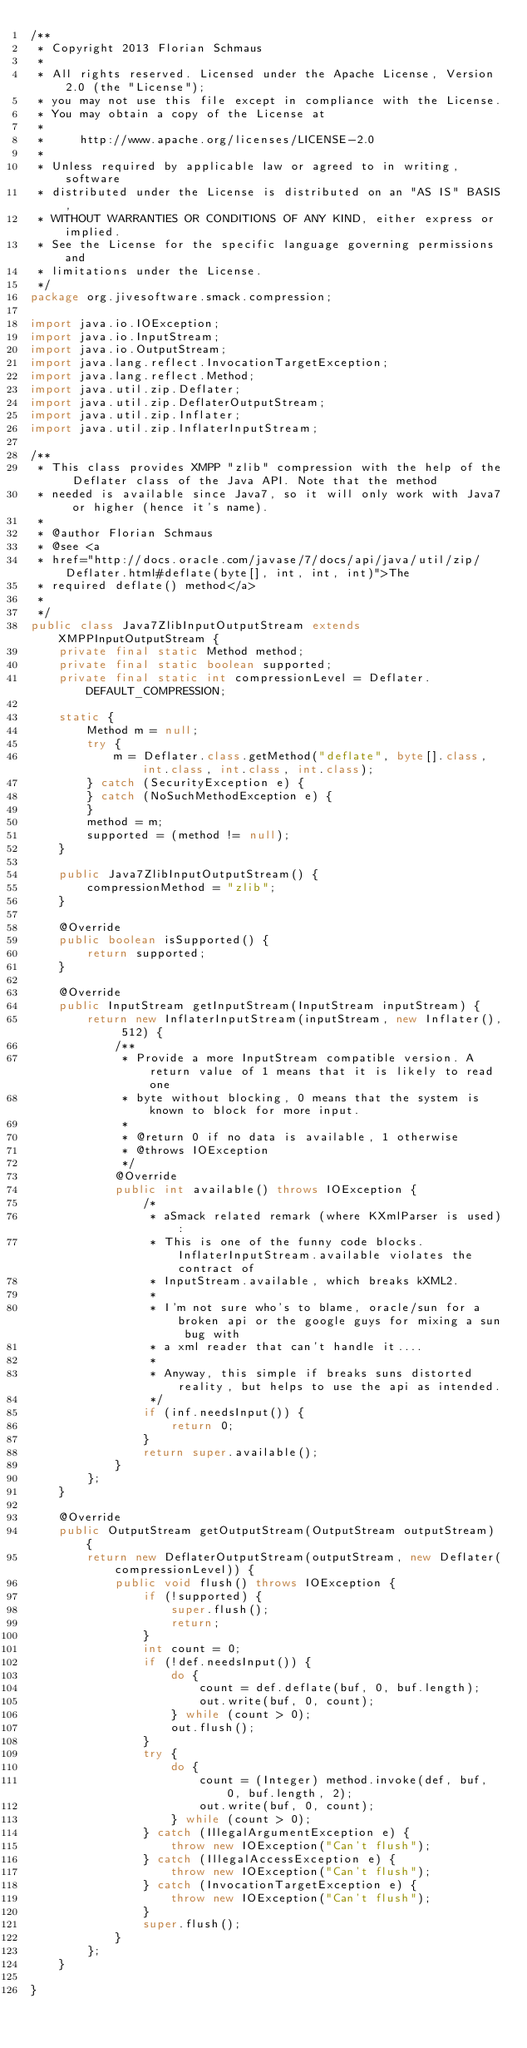Convert code to text. <code><loc_0><loc_0><loc_500><loc_500><_Java_>/**
 * Copyright 2013 Florian Schmaus
 *
 * All rights reserved. Licensed under the Apache License, Version 2.0 (the "License");
 * you may not use this file except in compliance with the License.
 * You may obtain a copy of the License at
 *
 *     http://www.apache.org/licenses/LICENSE-2.0
 *
 * Unless required by applicable law or agreed to in writing, software
 * distributed under the License is distributed on an "AS IS" BASIS,
 * WITHOUT WARRANTIES OR CONDITIONS OF ANY KIND, either express or implied.
 * See the License for the specific language governing permissions and
 * limitations under the License.
 */
package org.jivesoftware.smack.compression;

import java.io.IOException;
import java.io.InputStream;
import java.io.OutputStream;
import java.lang.reflect.InvocationTargetException;
import java.lang.reflect.Method;
import java.util.zip.Deflater;
import java.util.zip.DeflaterOutputStream;
import java.util.zip.Inflater;
import java.util.zip.InflaterInputStream;

/**
 * This class provides XMPP "zlib" compression with the help of the Deflater class of the Java API. Note that the method
 * needed is available since Java7, so it will only work with Java7 or higher (hence it's name).
 * 
 * @author Florian Schmaus
 * @see <a
 * href="http://docs.oracle.com/javase/7/docs/api/java/util/zip/Deflater.html#deflate(byte[], int, int, int)">The
 * required deflate() method</a>
 * 
 */
public class Java7ZlibInputOutputStream extends XMPPInputOutputStream {
    private final static Method method;
    private final static boolean supported;
    private final static int compressionLevel = Deflater.DEFAULT_COMPRESSION;

    static {
        Method m = null;
        try {
            m = Deflater.class.getMethod("deflate", byte[].class, int.class, int.class, int.class);
        } catch (SecurityException e) {
        } catch (NoSuchMethodException e) {
        }
        method = m;
        supported = (method != null);
    }

    public Java7ZlibInputOutputStream() {
        compressionMethod = "zlib";
    }

    @Override
    public boolean isSupported() {
        return supported;
    }

    @Override
    public InputStream getInputStream(InputStream inputStream) {
        return new InflaterInputStream(inputStream, new Inflater(), 512) {
            /**
             * Provide a more InputStream compatible version. A return value of 1 means that it is likely to read one
             * byte without blocking, 0 means that the system is known to block for more input.
             * 
             * @return 0 if no data is available, 1 otherwise
             * @throws IOException
             */
            @Override
            public int available() throws IOException {
                /*
                 * aSmack related remark (where KXmlParser is used):
                 * This is one of the funny code blocks. InflaterInputStream.available violates the contract of
                 * InputStream.available, which breaks kXML2.
                 * 
                 * I'm not sure who's to blame, oracle/sun for a broken api or the google guys for mixing a sun bug with
                 * a xml reader that can't handle it....
                 * 
                 * Anyway, this simple if breaks suns distorted reality, but helps to use the api as intended.
                 */
                if (inf.needsInput()) {
                    return 0;
                }
                return super.available();
            }
        };
    }

    @Override
    public OutputStream getOutputStream(OutputStream outputStream) {
        return new DeflaterOutputStream(outputStream, new Deflater(compressionLevel)) {
            public void flush() throws IOException {
                if (!supported) {
                    super.flush();
                    return;
                }
                int count = 0;
                if (!def.needsInput()) {
                    do {
                        count = def.deflate(buf, 0, buf.length);
                        out.write(buf, 0, count);
                    } while (count > 0);
                    out.flush();
                }
                try {
                    do {
                        count = (Integer) method.invoke(def, buf, 0, buf.length, 2);
                        out.write(buf, 0, count);
                    } while (count > 0);
                } catch (IllegalArgumentException e) {
                    throw new IOException("Can't flush");
                } catch (IllegalAccessException e) {
                    throw new IOException("Can't flush");
                } catch (InvocationTargetException e) {
                    throw new IOException("Can't flush");
                }
                super.flush();
            }
        };
    }

}
</code> 